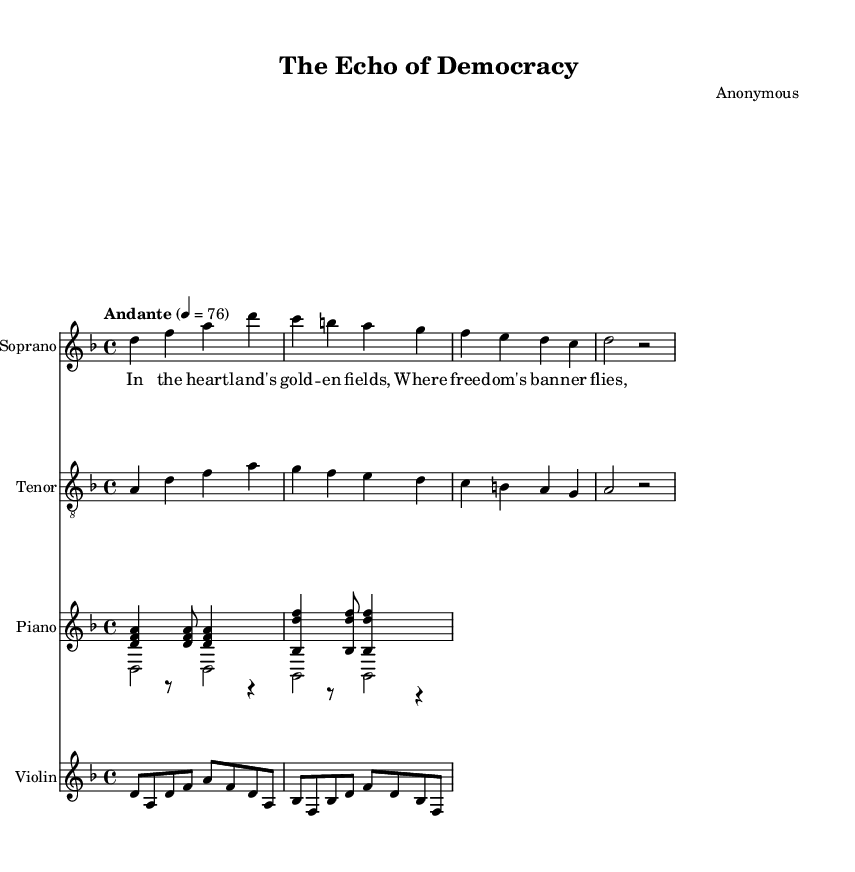What is the key signature of this music? The key signature is marked as D minor, which has one flat (the B flat). This can be identified by looking at the key signature found at the beginning of the staff.
Answer: D minor What is the time signature of the piece? The time signature is indicated as 4/4 at the beginning of the sheet music. This tells us that there are four beats per measure and a quarter note gets one beat.
Answer: 4/4 What is the tempo marking for this music? The tempo marking indicates "Andante" with a specific beat of 76, meaning it should be played at a moderate walking pace. This is given in the tempo directive at the start of the score.
Answer: Andante 4 = 76 How many staves are present in the score? The score contains a total of four distinct staves: one each for Soprano, Tenor, Piano, and Violin. This can be counted by observing each labeled staff in the score layout.
Answer: Four What is the pattern of the first four notes in the soprano line? The first four notes of the soprano line are D, F, A, D, which form a D minor chord. This is determined by looking at the note values in the soprano section.
Answer: D, F, A, D What type of music is this sheet representing? This sheet represents an opera, as indicated by the title "The Echo of Democracy" and the presence of vocal lines with orchestral accompaniment. This is typical of operatic music forms.
Answer: Opera 